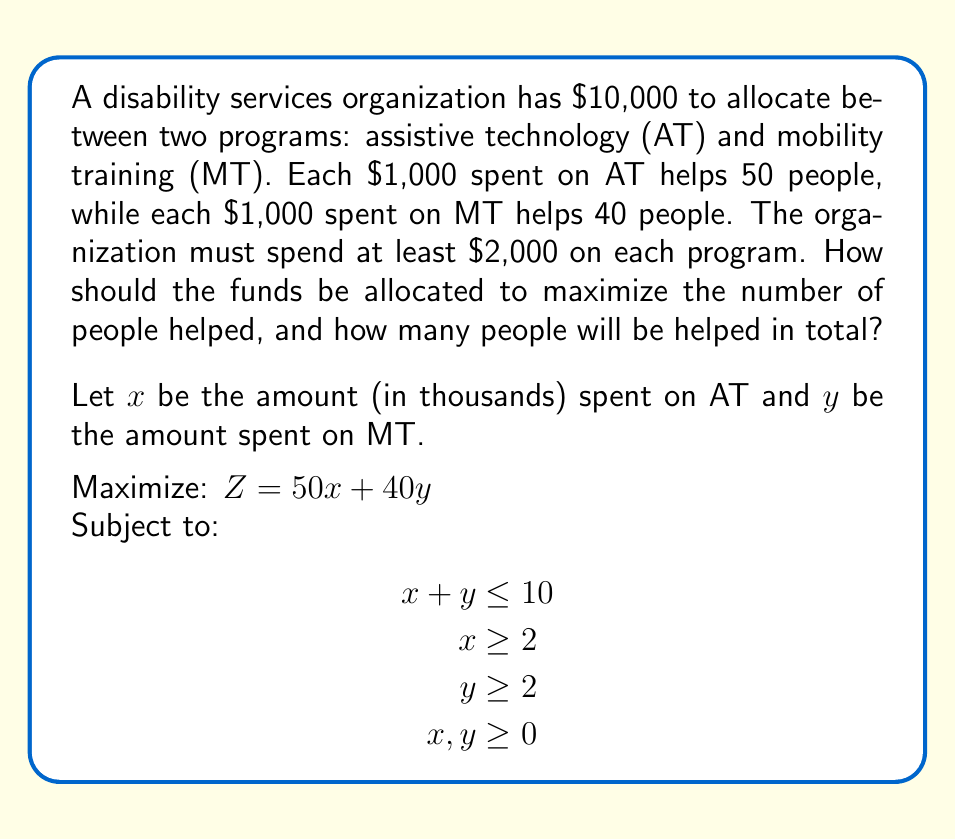Help me with this question. To solve this linear programming problem, we'll use the graphical method:

1. Plot the constraints:
   $x + y = 10$ (budget constraint)
   $x = 2$ (minimum AT spending)
   $y = 2$ (minimum MT spending)

2. Identify the feasible region:
   The feasible region is the area that satisfies all constraints.

3. Find the corner points of the feasible region:
   A (2, 2), B (2, 8), C (8, 2)

4. Evaluate the objective function at each corner point:
   A: $Z = 50(2) + 40(2) = 180$
   B: $Z = 50(2) + 40(8) = 420$
   C: $Z = 50(8) + 40(2) = 480$

5. The maximum value occurs at point C (8, 2).

Therefore, the optimal allocation is:
- $8,000 for assistive technology
- $2,000 for mobility training

The total number of people helped:
$50(8) + 40(2) = 400 + 80 = 480$
Answer: $8,000 on AT, $2,000 on MT; 480 people helped 